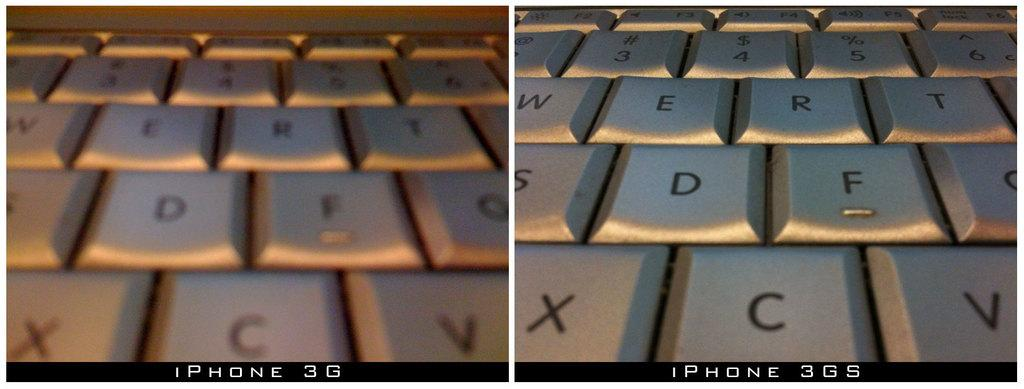Provide a one-sentence caption for the provided image. Two close ups of a keyboard, with XCV on the bottom row of the right one. 